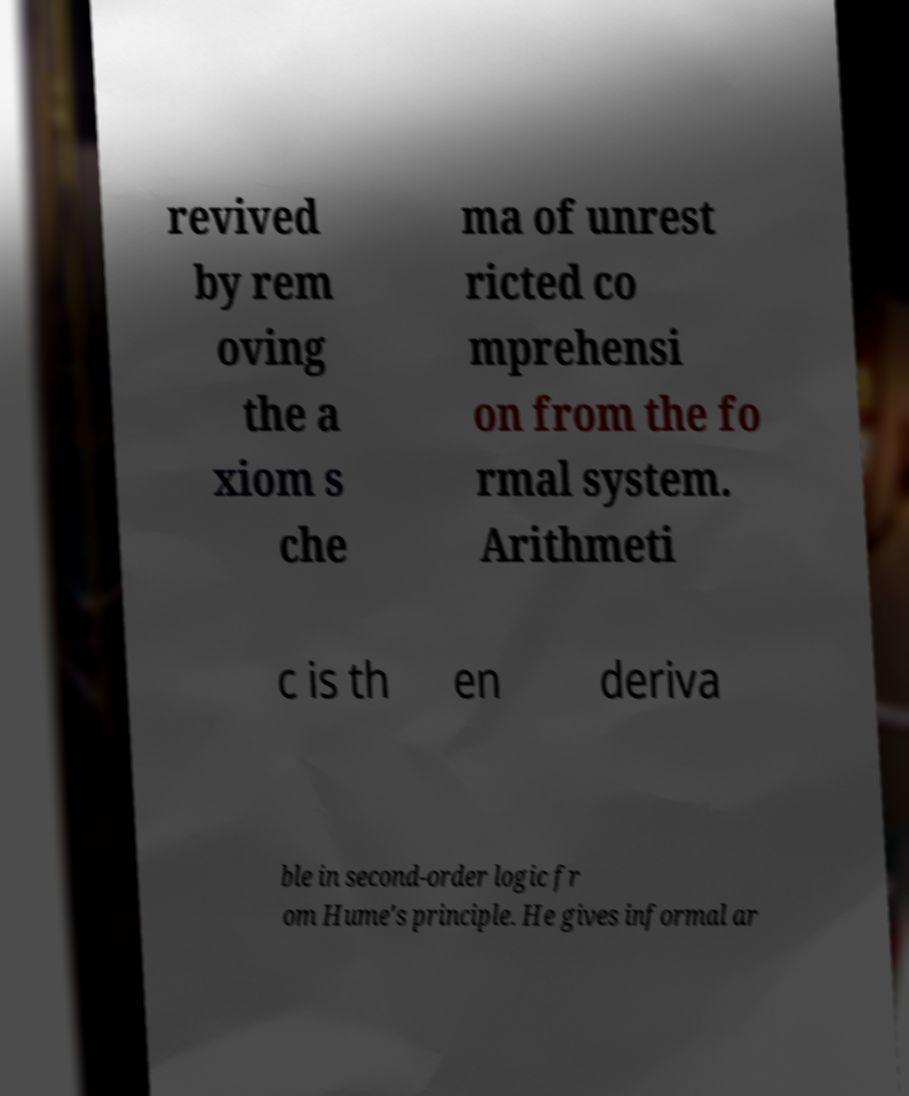Can you read and provide the text displayed in the image?This photo seems to have some interesting text. Can you extract and type it out for me? revived by rem oving the a xiom s che ma of unrest ricted co mprehensi on from the fo rmal system. Arithmeti c is th en deriva ble in second-order logic fr om Hume's principle. He gives informal ar 